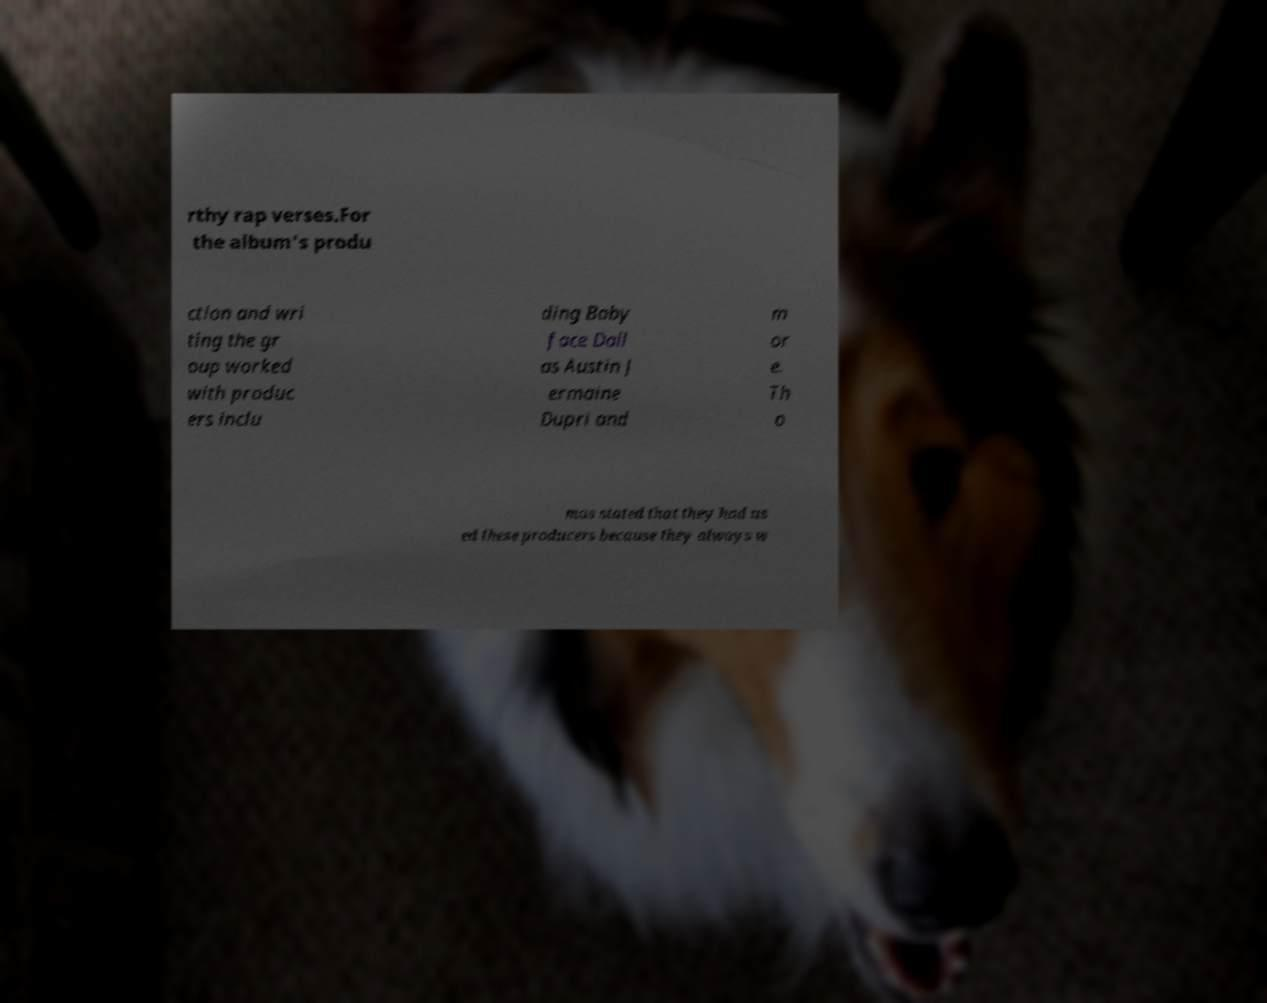Please read and relay the text visible in this image. What does it say? rthy rap verses.For the album's produ ction and wri ting the gr oup worked with produc ers inclu ding Baby face Dall as Austin J ermaine Dupri and m or e. Th o mas stated that they had us ed these producers because they always w 